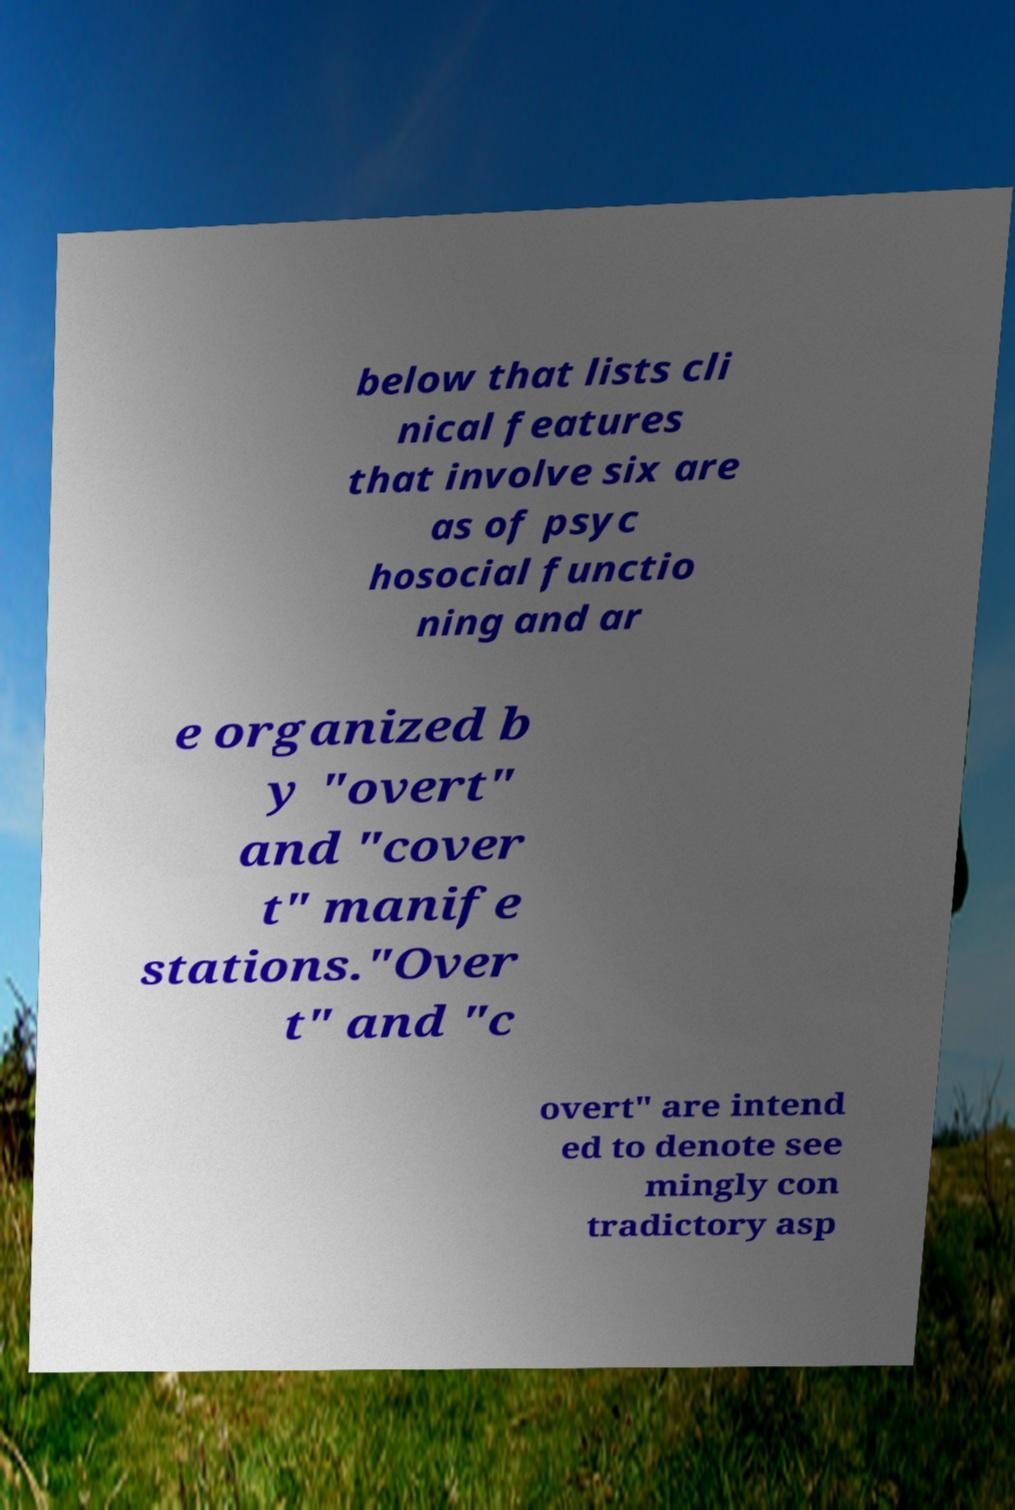What messages or text are displayed in this image? I need them in a readable, typed format. below that lists cli nical features that involve six are as of psyc hosocial functio ning and ar e organized b y "overt" and "cover t" manife stations."Over t" and "c overt" are intend ed to denote see mingly con tradictory asp 